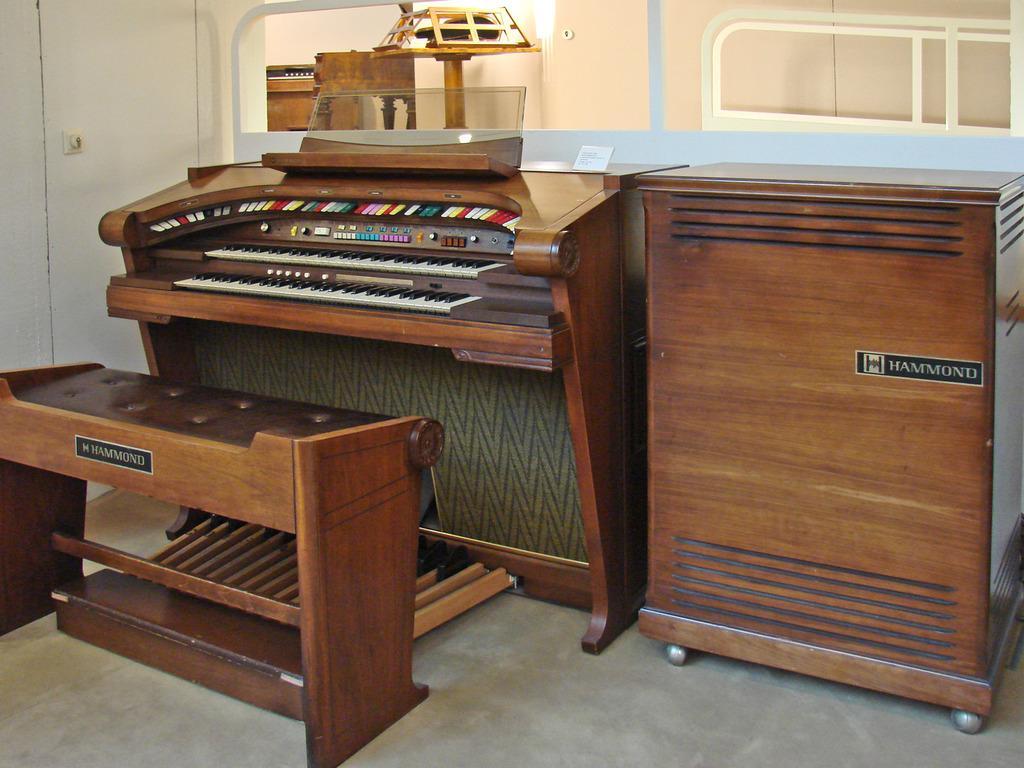How would you summarize this image in a sentence or two? This image is taken indoors. At the bottom of the image there is a floor. In the background there is a wall with a window. On the left side of the image there is a couch which is made of wood. In the middle of the image there is a keyboard and there is a cupboard. 